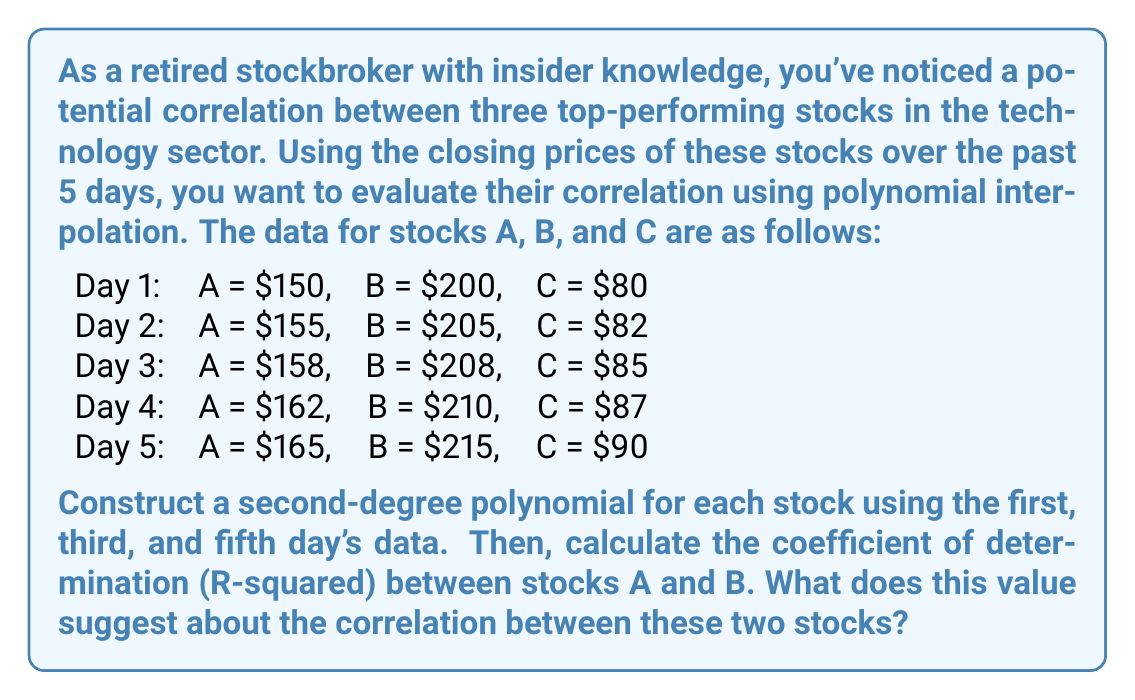Solve this math problem. To solve this problem, we'll follow these steps:

1. Construct second-degree polynomials for stocks A and B using the data from days 1, 3, and 5.
2. Calculate the coefficient of determination (R-squared) between stocks A and B.
3. Interpret the results.

Step 1: Constructing second-degree polynomials

For each stock, we'll use the form $f(x) = ax^2 + bx + c$, where x represents the day number.

For Stock A:
Day 1: $150 = a(1)^2 + b(1) + c$
Day 3: $158 = a(3)^2 + b(3) + c$
Day 5: $165 = a(5)^2 + b(5) + c$

Solving this system of equations gives us:
$f_A(x) = -0.5x^2 + 8x + 142.5$

For Stock B:
Day 1: $200 = a(1)^2 + b(1) + c$
Day 3: $208 = a(3)^2 + b(3) + c$
Day 5: $215 = a(5)^2 + b(5) + c$

Solving this system of equations gives us:
$f_B(x) = -0.25x^2 + 5.75x + 194.5$

Step 2: Calculating the coefficient of determination (R-squared)

To calculate R-squared, we'll use the formula:

$R^2 = 1 - \frac{\sum_{i=1}^n (y_i - \hat{y}_i)^2}{\sum_{i=1}^n (y_i - \bar{y})^2}$

Where:
$y_i$ are the actual values of stock B
$\hat{y}_i$ are the predicted values of stock B using the polynomial for stock A
$\bar{y}$ is the mean of the actual values of stock B

First, we need to scale the polynomial for stock A to match the range of stock B:

$f_{A_{scaled}}(x) = 1.3333f_A(x) + 0.6667$

Now we can calculate the predicted values for stock B using $f_{A_{scaled}}(x)$:

Day 1: $\hat{y}_1 = 191.3333$
Day 2: $\hat{y}_2 = 202.2667$
Day 3: $\hat{y}_3 = 209.8667$
Day 4: $\hat{y}_4 = 214.1333$
Day 5: $\hat{y}_5 = 215.0667$

Calculating the sums:

$\sum_{i=1}^n (y_i - \hat{y}_i)^2 = 94.2222$
$\sum_{i=1}^n (y_i - \bar{y})^2 = 112.5$

Now we can calculate R-squared:

$R^2 = 1 - \frac{94.2222}{112.5} = 0.1627$

Step 3: Interpreting the results

The R-squared value of 0.1627 suggests a weak correlation between stocks A and B. This means that only about 16.27% of the variance in stock B's price can be explained by the relationship with stock A's price.
Answer: The coefficient of determination (R-squared) between stocks A and B is 0.1627, suggesting a weak correlation between the two stocks. Only about 16.27% of the variance in stock B's price can be explained by its relationship with stock A's price. 